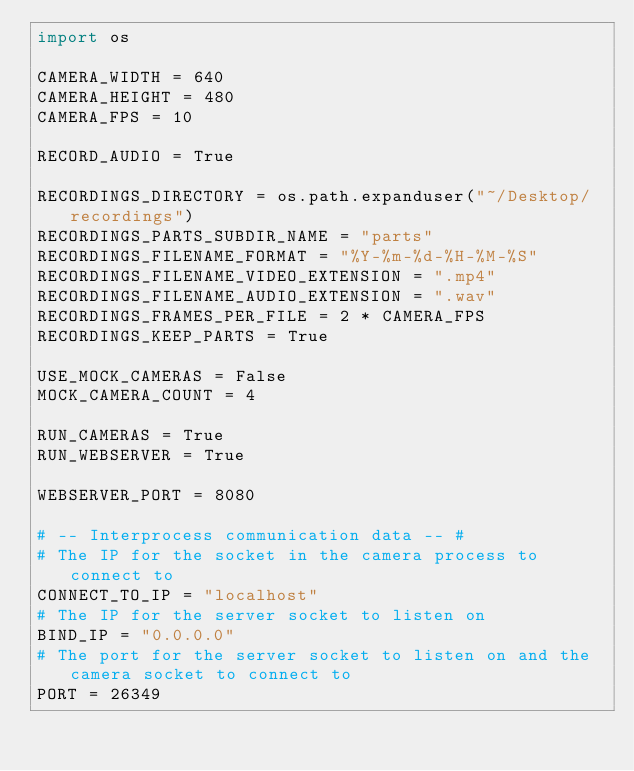Convert code to text. <code><loc_0><loc_0><loc_500><loc_500><_Python_>import os

CAMERA_WIDTH = 640
CAMERA_HEIGHT = 480
CAMERA_FPS = 10

RECORD_AUDIO = True

RECORDINGS_DIRECTORY = os.path.expanduser("~/Desktop/recordings")
RECORDINGS_PARTS_SUBDIR_NAME = "parts"
RECORDINGS_FILENAME_FORMAT = "%Y-%m-%d-%H-%M-%S"
RECORDINGS_FILENAME_VIDEO_EXTENSION = ".mp4"
RECORDINGS_FILENAME_AUDIO_EXTENSION = ".wav"
RECORDINGS_FRAMES_PER_FILE = 2 * CAMERA_FPS
RECORDINGS_KEEP_PARTS = True

USE_MOCK_CAMERAS = False
MOCK_CAMERA_COUNT = 4

RUN_CAMERAS = True
RUN_WEBSERVER = True

WEBSERVER_PORT = 8080

# -- Interprocess communication data -- #
# The IP for the socket in the camera process to connect to
CONNECT_TO_IP = "localhost"
# The IP for the server socket to listen on
BIND_IP = "0.0.0.0"
# The port for the server socket to listen on and the camera socket to connect to
PORT = 26349
</code> 